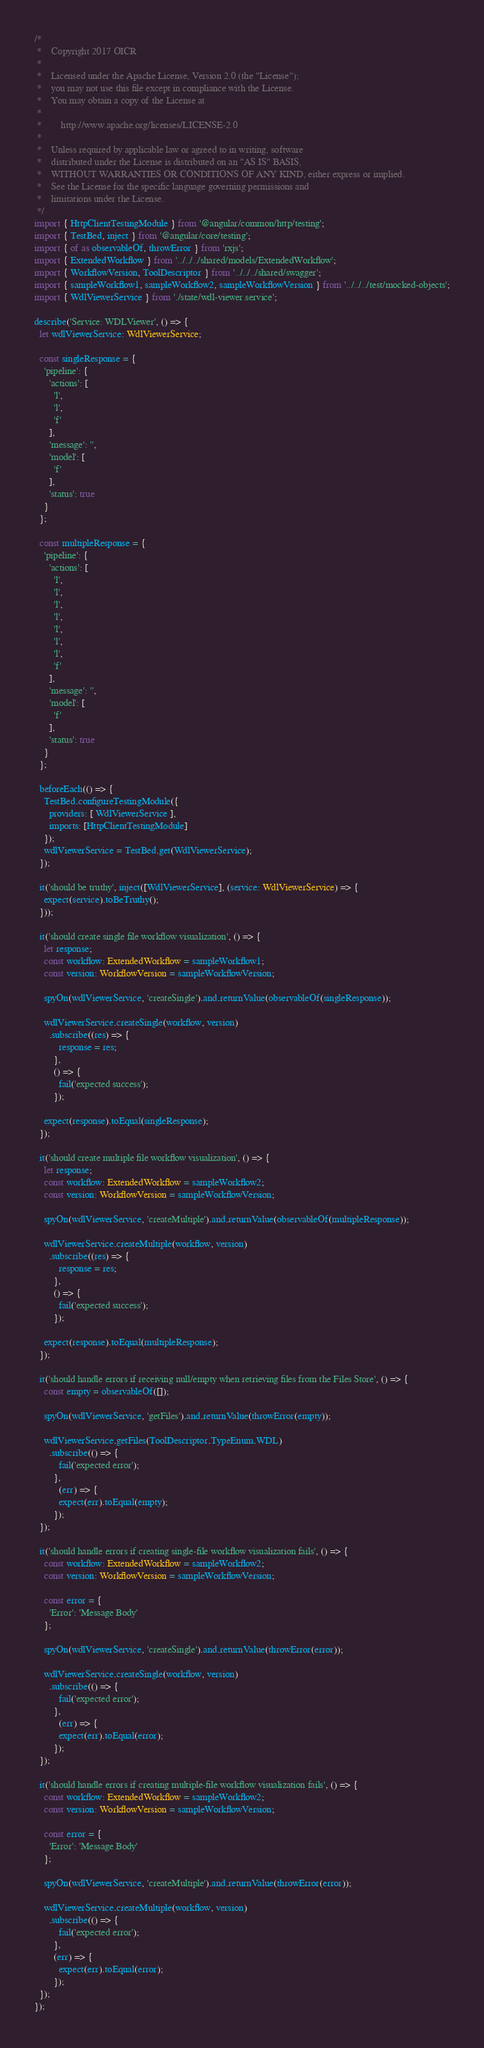<code> <loc_0><loc_0><loc_500><loc_500><_TypeScript_>/*
 *    Copyright 2017 OICR
 *
 *    Licensed under the Apache License, Version 2.0 (the "License");
 *    you may not use this file except in compliance with the License.
 *    You may obtain a copy of the License at
 *
 *        http://www.apache.org/licenses/LICENSE-2.0
 *
 *    Unless required by applicable law or agreed to in writing, software
 *    distributed under the License is distributed on an "AS IS" BASIS,
 *    WITHOUT WARRANTIES OR CONDITIONS OF ANY KIND, either express or implied.
 *    See the License for the specific language governing permissions and
 *    limitations under the License.
 */
import { HttpClientTestingModule } from '@angular/common/http/testing';
import { TestBed, inject } from '@angular/core/testing';
import { of as observableOf, throwError } from 'rxjs';
import { ExtendedWorkflow } from '../../../shared/models/ExtendedWorkflow';
import { WorkflowVersion, ToolDescriptor } from '../../../shared/swagger';
import { sampleWorkflow1, sampleWorkflow2, sampleWorkflowVersion } from '../../../test/mocked-objects';
import { WdlViewerService } from './state/wdl-viewer.service';

describe('Service: WDLViewer', () => {
  let wdlViewerService: WdlViewerService;

  const singleResponse = {
    'pipeline': {
      'actions': [
        'l',
        'l',
        'f'
      ],
      'message': '',
      'model': [
        'f'
      ],
      'status': true
    }
  };

  const multipleResponse = {
    'pipeline': {
      'actions': [
        'l',
        'l',
        'l',
        'l',
        'l',
        'l',
        'l',
        'f'
      ],
      'message': '',
      'model': [
        'f'
      ],
      'status': true
    }
  };

  beforeEach(() => {
    TestBed.configureTestingModule({
      providers: [ WdlViewerService ],
      imports: [HttpClientTestingModule]
    });
    wdlViewerService = TestBed.get(WdlViewerService);
  });

  it('should be truthy', inject([WdlViewerService], (service: WdlViewerService) => {
    expect(service).toBeTruthy();
  }));

  it('should create single file workflow visualization', () => {
    let response;
    const workflow: ExtendedWorkflow = sampleWorkflow1;
    const version: WorkflowVersion = sampleWorkflowVersion;

    spyOn(wdlViewerService, 'createSingle').and.returnValue(observableOf(singleResponse));

    wdlViewerService.createSingle(workflow, version)
      .subscribe((res) => {
          response = res;
        },
        () => {
          fail('expected success');
        });

    expect(response).toEqual(singleResponse);
  });

  it('should create multiple file workflow visualization', () => {
    let response;
    const workflow: ExtendedWorkflow = sampleWorkflow2;
    const version: WorkflowVersion = sampleWorkflowVersion;

    spyOn(wdlViewerService, 'createMultiple').and.returnValue(observableOf(multipleResponse));

    wdlViewerService.createMultiple(workflow, version)
      .subscribe((res) => {
          response = res;
        },
        () => {
          fail('expected success');
        });

    expect(response).toEqual(multipleResponse);
  });

  it('should handle errors if receiving null/empty when retrieving files from the Files Store', () => {
    const empty = observableOf([]);

    spyOn(wdlViewerService, 'getFiles').and.returnValue(throwError(empty));

    wdlViewerService.getFiles(ToolDescriptor.TypeEnum.WDL)
      .subscribe(() => {
          fail('expected error');
        },
          (err) => {
          expect(err).toEqual(empty);
        });
  });

  it('should handle errors if creating single-file workflow visualization fails', () => {
    const workflow: ExtendedWorkflow = sampleWorkflow2;
    const version: WorkflowVersion = sampleWorkflowVersion;

    const error = {
      'Error': 'Message Body'
    };

    spyOn(wdlViewerService, 'createSingle').and.returnValue(throwError(error));

    wdlViewerService.createSingle(workflow, version)
      .subscribe(() => {
          fail('expected error');
        },
          (err) => {
          expect(err).toEqual(error);
        });
  });

  it('should handle errors if creating multiple-file workflow visualization fails', () => {
    const workflow: ExtendedWorkflow = sampleWorkflow2;
    const version: WorkflowVersion = sampleWorkflowVersion;

    const error = {
      'Error': 'Message Body'
    };

    spyOn(wdlViewerService, 'createMultiple').and.returnValue(throwError(error));

    wdlViewerService.createMultiple(workflow, version)
      .subscribe(() => {
          fail('expected error');
        },
        (err) => {
          expect(err).toEqual(error);
        });
  });
});
</code> 